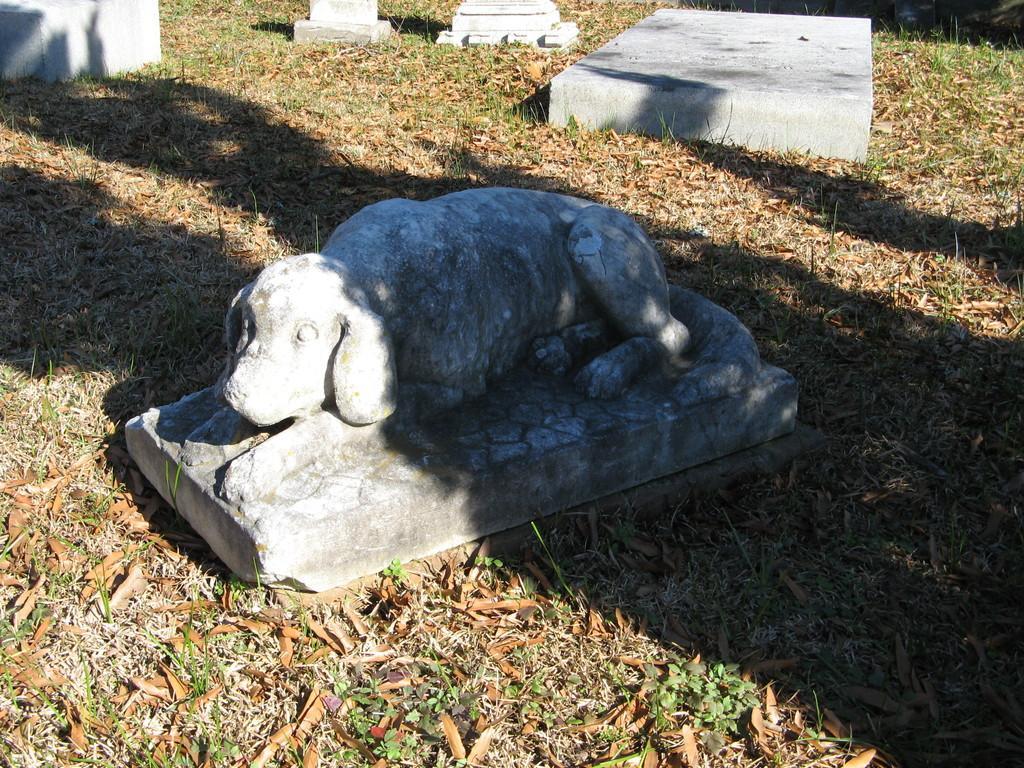Can you describe this image briefly? In this image we can see the dog sculpture. We can also see the concrete blocks. In the background we can see the grass and also the dried leaves. 